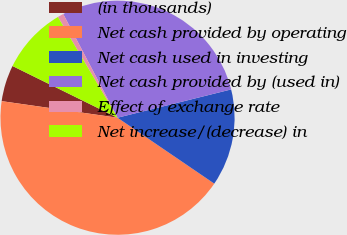Convert chart. <chart><loc_0><loc_0><loc_500><loc_500><pie_chart><fcel>(in thousands)<fcel>Net cash provided by operating<fcel>Net cash used in investing<fcel>Net cash provided by (used in)<fcel>Effect of exchange rate<fcel>Net increase/(decrease) in<nl><fcel>5.02%<fcel>42.74%<fcel>13.4%<fcel>28.79%<fcel>0.83%<fcel>9.21%<nl></chart> 